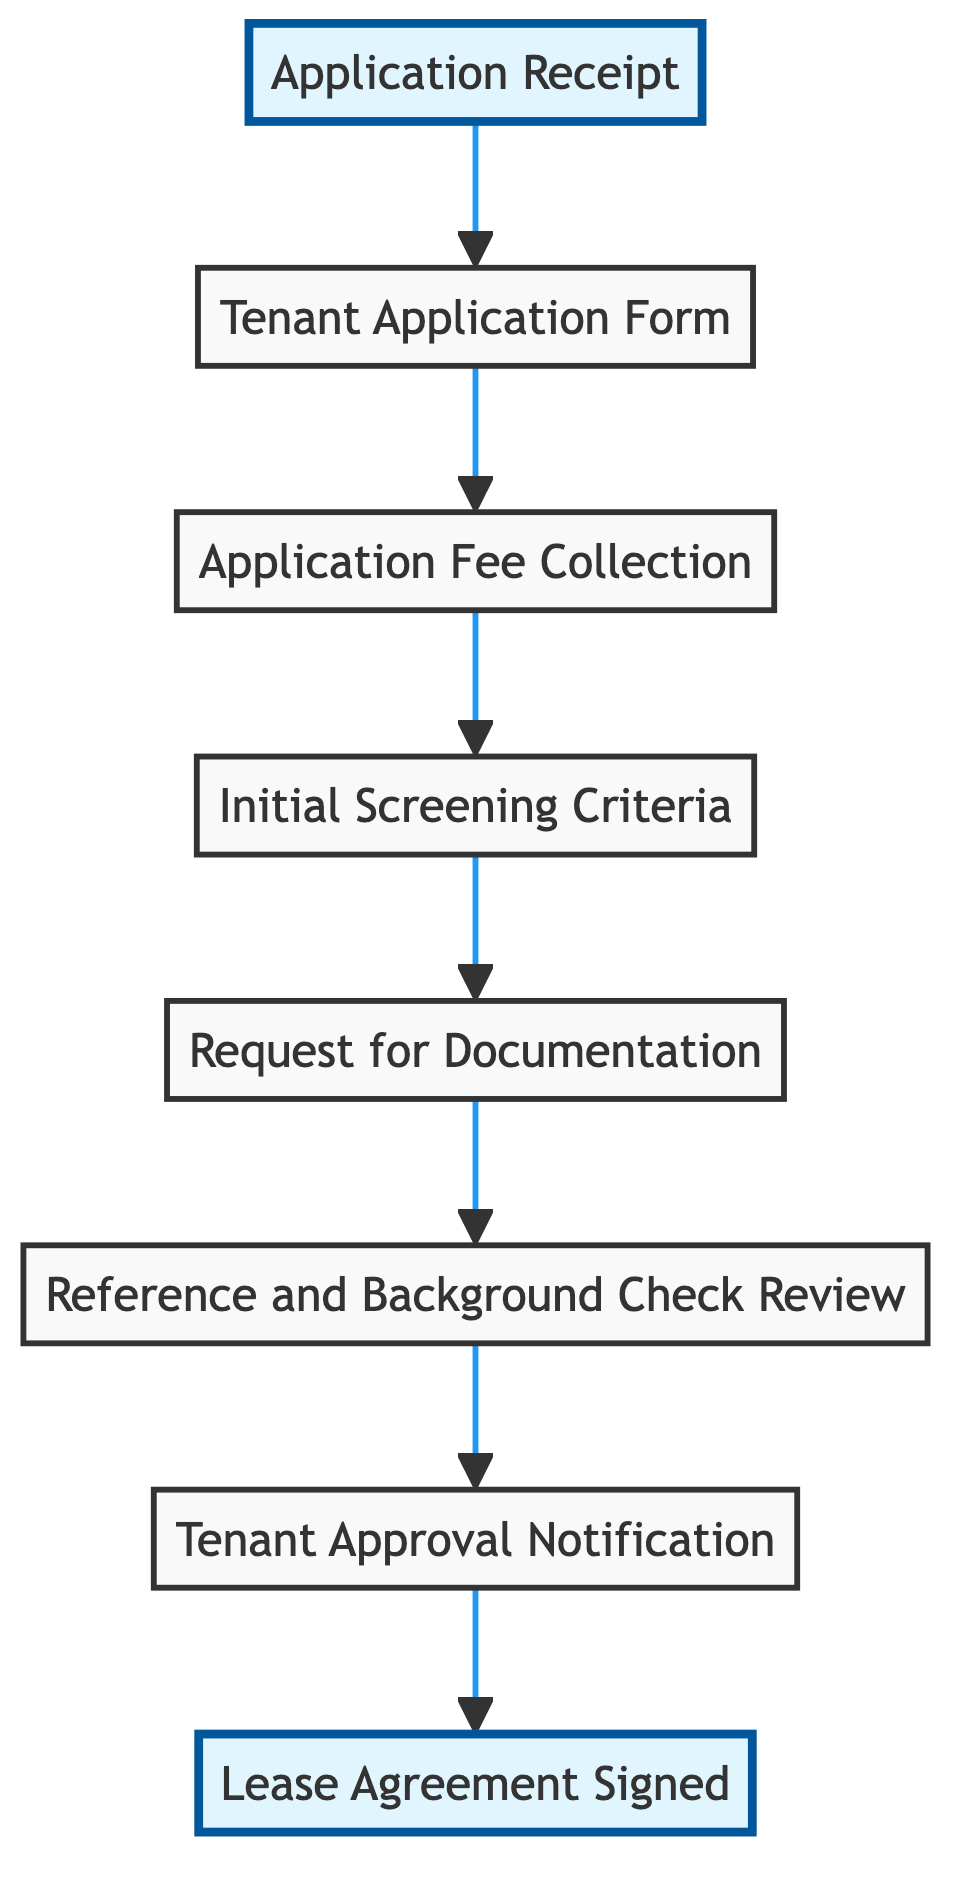What is the last step of the tenant screening procedure? The last step of the procedure is indicated by the flow's top node, which is "Lease Agreement Signed." This signifies the formal conclusion of the process.
Answer: Lease Agreement Signed How many nodes are in the diagram? There are eight nodes in the diagram, as counted from the elements listed in the data. Each node represents a step in the tenant screening process.
Answer: 8 What do you do after receiving the tenant application form? The next step after receiving the tenant application form is "Application Fee Collection," which is directly linked to the tenant application form in the flow. This signifies the need to collect processing fees.
Answer: Application Fee Collection What is required before notifying the tenant of approval? Before notifying the tenant of approval, "Reference and Background Check Review" must be completed. This means evaluating background information is necessary prior to approval alerts.
Answer: Reference and Background Check Review What action follows the initial screening criteria? After applying the initial screening criteria, the next action is to "Request for Documentation." This indicates that more documentation is needed following the initial assessment of tenants.
Answer: Request for Documentation Which step comes immediately after the application receipt? The step that comes immediately after "Application Receipt" is "Tenant Application Form." This shows that the application form is the next thing to be handled after acknowledging its receipt.
Answer: Tenant Application Form What step can't occur without collecting an application fee? The "Initial Screening Criteria" step cannot occur without first collecting the application fee. This is a prerequisite emphasized in the flow.
Answer: Initial Screening Criteria What notification is given after reference checks are reviewed? After reviewing the reference checks, "Tenant Approval Notification" is given to the chosen tenant. This indicates the successful candidate is informed once checks are complete.
Answer: Tenant Approval Notification 